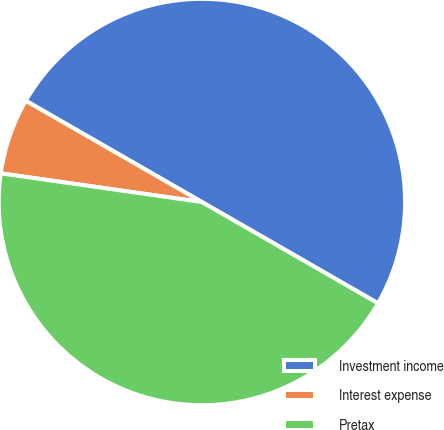Convert chart to OTSL. <chart><loc_0><loc_0><loc_500><loc_500><pie_chart><fcel>Investment income<fcel>Interest expense<fcel>Pretax<nl><fcel>50.0%<fcel>6.05%<fcel>43.95%<nl></chart> 